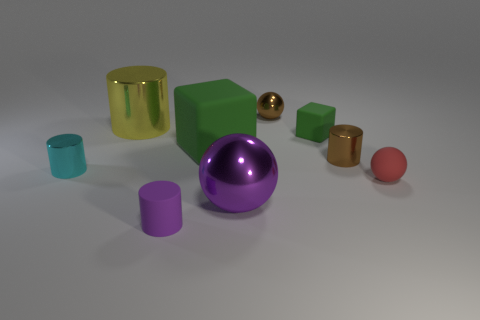What is the size of the brown metal object that is the same shape as the tiny purple rubber object?
Offer a very short reply. Small. Is there anything else that is the same material as the yellow cylinder?
Your answer should be compact. Yes. Is there a tiny green thing that is to the right of the tiny ball in front of the brown thing in front of the big cylinder?
Provide a succinct answer. No. There is a small ball that is on the right side of the brown cylinder; what is it made of?
Your answer should be very brief. Rubber. How many tiny things are either shiny spheres or balls?
Your answer should be compact. 2. There is a block that is to the left of the purple sphere; is its size the same as the brown cylinder?
Give a very brief answer. No. What number of other objects are the same color as the matte sphere?
Give a very brief answer. 0. What is the tiny brown cylinder made of?
Give a very brief answer. Metal. There is a tiny object that is both on the left side of the big purple shiny ball and behind the purple matte cylinder; what material is it made of?
Ensure brevity in your answer.  Metal. What number of things are large objects on the right side of the large yellow metal cylinder or shiny balls?
Your answer should be compact. 3. 